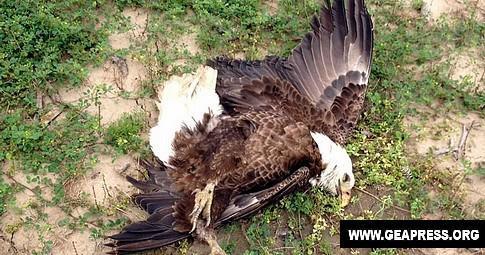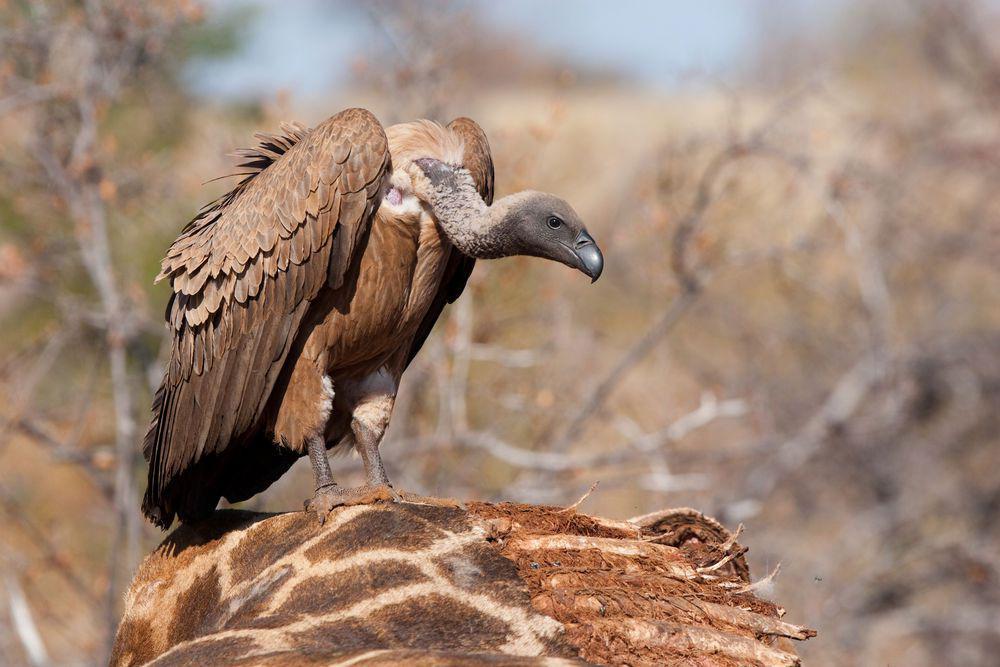The first image is the image on the left, the second image is the image on the right. Given the left and right images, does the statement "There are two vultures in the image pair" hold true? Answer yes or no. Yes. 